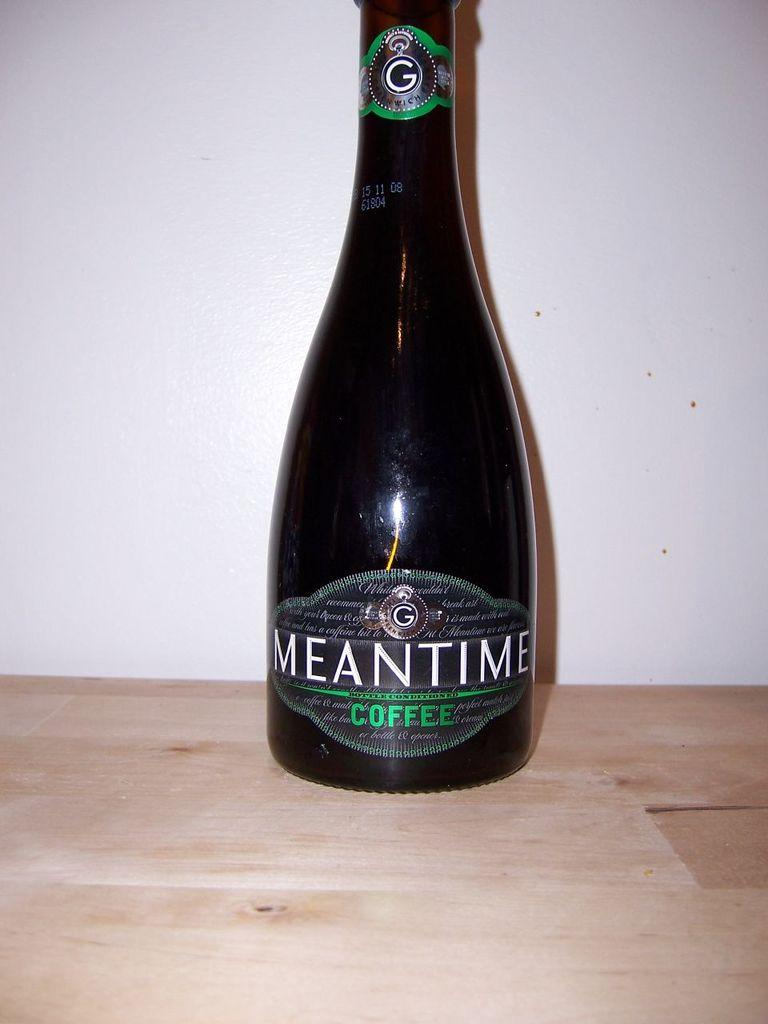<image>
Provide a brief description of the given image. A bottle of Meantime coffee is on a wooden countertop. 